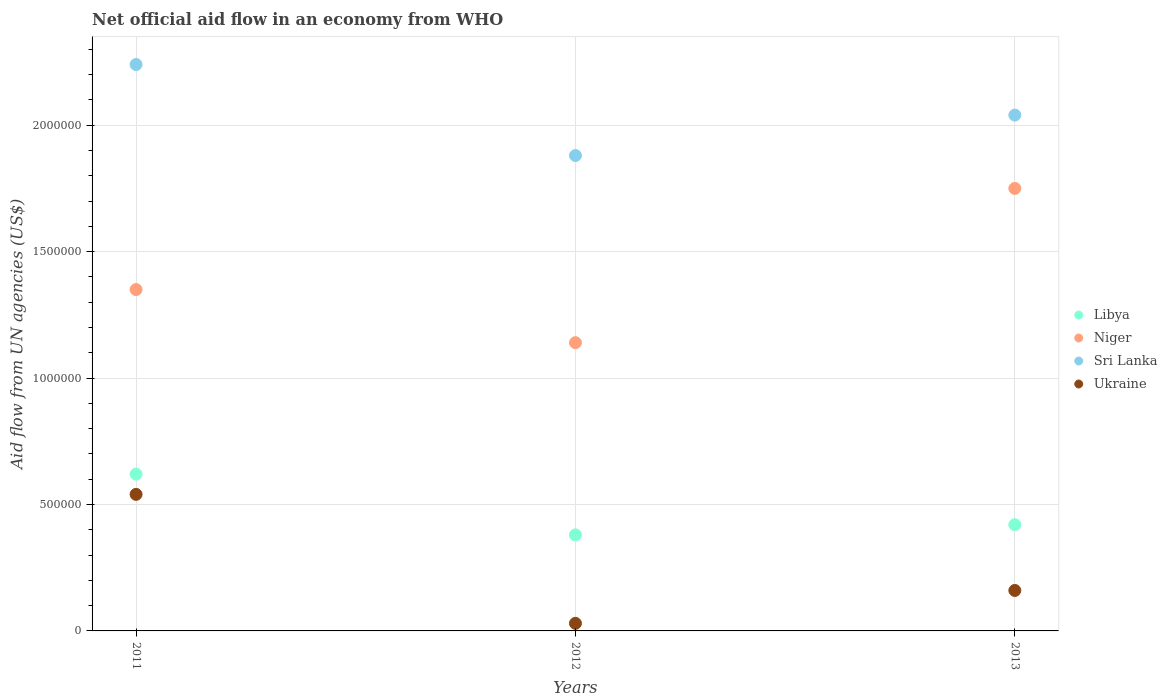Is the number of dotlines equal to the number of legend labels?
Your answer should be compact. Yes. Across all years, what is the maximum net official aid flow in Libya?
Offer a very short reply. 6.20e+05. Across all years, what is the minimum net official aid flow in Niger?
Ensure brevity in your answer.  1.14e+06. In which year was the net official aid flow in Ukraine minimum?
Your response must be concise. 2012. What is the total net official aid flow in Niger in the graph?
Keep it short and to the point. 4.24e+06. What is the difference between the net official aid flow in Niger in 2011 and the net official aid flow in Sri Lanka in 2013?
Your response must be concise. -6.90e+05. What is the average net official aid flow in Niger per year?
Offer a very short reply. 1.41e+06. In the year 2013, what is the difference between the net official aid flow in Ukraine and net official aid flow in Niger?
Offer a terse response. -1.59e+06. In how many years, is the net official aid flow in Ukraine greater than 1800000 US$?
Provide a succinct answer. 0. What is the ratio of the net official aid flow in Ukraine in 2011 to that in 2013?
Make the answer very short. 3.38. Is the net official aid flow in Ukraine in 2011 less than that in 2013?
Provide a short and direct response. No. In how many years, is the net official aid flow in Niger greater than the average net official aid flow in Niger taken over all years?
Your answer should be compact. 1. Is it the case that in every year, the sum of the net official aid flow in Ukraine and net official aid flow in Libya  is greater than the sum of net official aid flow in Niger and net official aid flow in Sri Lanka?
Ensure brevity in your answer.  No. Is it the case that in every year, the sum of the net official aid flow in Ukraine and net official aid flow in Libya  is greater than the net official aid flow in Sri Lanka?
Make the answer very short. No. Does the net official aid flow in Niger monotonically increase over the years?
Provide a succinct answer. No. Is the net official aid flow in Niger strictly less than the net official aid flow in Sri Lanka over the years?
Provide a succinct answer. Yes. How many dotlines are there?
Give a very brief answer. 4. What is the difference between two consecutive major ticks on the Y-axis?
Keep it short and to the point. 5.00e+05. Are the values on the major ticks of Y-axis written in scientific E-notation?
Provide a succinct answer. No. What is the title of the graph?
Offer a very short reply. Net official aid flow in an economy from WHO. Does "Cambodia" appear as one of the legend labels in the graph?
Ensure brevity in your answer.  No. What is the label or title of the X-axis?
Keep it short and to the point. Years. What is the label or title of the Y-axis?
Keep it short and to the point. Aid flow from UN agencies (US$). What is the Aid flow from UN agencies (US$) in Libya in 2011?
Offer a very short reply. 6.20e+05. What is the Aid flow from UN agencies (US$) of Niger in 2011?
Give a very brief answer. 1.35e+06. What is the Aid flow from UN agencies (US$) in Sri Lanka in 2011?
Provide a short and direct response. 2.24e+06. What is the Aid flow from UN agencies (US$) of Ukraine in 2011?
Your answer should be very brief. 5.40e+05. What is the Aid flow from UN agencies (US$) in Libya in 2012?
Provide a succinct answer. 3.80e+05. What is the Aid flow from UN agencies (US$) of Niger in 2012?
Give a very brief answer. 1.14e+06. What is the Aid flow from UN agencies (US$) in Sri Lanka in 2012?
Provide a short and direct response. 1.88e+06. What is the Aid flow from UN agencies (US$) of Libya in 2013?
Offer a terse response. 4.20e+05. What is the Aid flow from UN agencies (US$) of Niger in 2013?
Give a very brief answer. 1.75e+06. What is the Aid flow from UN agencies (US$) in Sri Lanka in 2013?
Offer a very short reply. 2.04e+06. Across all years, what is the maximum Aid flow from UN agencies (US$) in Libya?
Make the answer very short. 6.20e+05. Across all years, what is the maximum Aid flow from UN agencies (US$) of Niger?
Your response must be concise. 1.75e+06. Across all years, what is the maximum Aid flow from UN agencies (US$) of Sri Lanka?
Offer a very short reply. 2.24e+06. Across all years, what is the maximum Aid flow from UN agencies (US$) in Ukraine?
Your response must be concise. 5.40e+05. Across all years, what is the minimum Aid flow from UN agencies (US$) of Libya?
Your response must be concise. 3.80e+05. Across all years, what is the minimum Aid flow from UN agencies (US$) in Niger?
Your answer should be compact. 1.14e+06. Across all years, what is the minimum Aid flow from UN agencies (US$) in Sri Lanka?
Offer a very short reply. 1.88e+06. What is the total Aid flow from UN agencies (US$) in Libya in the graph?
Offer a terse response. 1.42e+06. What is the total Aid flow from UN agencies (US$) in Niger in the graph?
Your answer should be compact. 4.24e+06. What is the total Aid flow from UN agencies (US$) of Sri Lanka in the graph?
Provide a succinct answer. 6.16e+06. What is the total Aid flow from UN agencies (US$) of Ukraine in the graph?
Your answer should be very brief. 7.30e+05. What is the difference between the Aid flow from UN agencies (US$) of Libya in 2011 and that in 2012?
Ensure brevity in your answer.  2.40e+05. What is the difference between the Aid flow from UN agencies (US$) of Ukraine in 2011 and that in 2012?
Your response must be concise. 5.10e+05. What is the difference between the Aid flow from UN agencies (US$) of Libya in 2011 and that in 2013?
Offer a terse response. 2.00e+05. What is the difference between the Aid flow from UN agencies (US$) of Niger in 2011 and that in 2013?
Ensure brevity in your answer.  -4.00e+05. What is the difference between the Aid flow from UN agencies (US$) of Libya in 2012 and that in 2013?
Keep it short and to the point. -4.00e+04. What is the difference between the Aid flow from UN agencies (US$) of Niger in 2012 and that in 2013?
Your response must be concise. -6.10e+05. What is the difference between the Aid flow from UN agencies (US$) of Sri Lanka in 2012 and that in 2013?
Your answer should be compact. -1.60e+05. What is the difference between the Aid flow from UN agencies (US$) in Ukraine in 2012 and that in 2013?
Keep it short and to the point. -1.30e+05. What is the difference between the Aid flow from UN agencies (US$) in Libya in 2011 and the Aid flow from UN agencies (US$) in Niger in 2012?
Ensure brevity in your answer.  -5.20e+05. What is the difference between the Aid flow from UN agencies (US$) in Libya in 2011 and the Aid flow from UN agencies (US$) in Sri Lanka in 2012?
Your response must be concise. -1.26e+06. What is the difference between the Aid flow from UN agencies (US$) of Libya in 2011 and the Aid flow from UN agencies (US$) of Ukraine in 2012?
Your answer should be compact. 5.90e+05. What is the difference between the Aid flow from UN agencies (US$) of Niger in 2011 and the Aid flow from UN agencies (US$) of Sri Lanka in 2012?
Your answer should be very brief. -5.30e+05. What is the difference between the Aid flow from UN agencies (US$) of Niger in 2011 and the Aid flow from UN agencies (US$) of Ukraine in 2012?
Make the answer very short. 1.32e+06. What is the difference between the Aid flow from UN agencies (US$) of Sri Lanka in 2011 and the Aid flow from UN agencies (US$) of Ukraine in 2012?
Your answer should be very brief. 2.21e+06. What is the difference between the Aid flow from UN agencies (US$) in Libya in 2011 and the Aid flow from UN agencies (US$) in Niger in 2013?
Keep it short and to the point. -1.13e+06. What is the difference between the Aid flow from UN agencies (US$) in Libya in 2011 and the Aid flow from UN agencies (US$) in Sri Lanka in 2013?
Ensure brevity in your answer.  -1.42e+06. What is the difference between the Aid flow from UN agencies (US$) of Niger in 2011 and the Aid flow from UN agencies (US$) of Sri Lanka in 2013?
Offer a very short reply. -6.90e+05. What is the difference between the Aid flow from UN agencies (US$) of Niger in 2011 and the Aid flow from UN agencies (US$) of Ukraine in 2013?
Keep it short and to the point. 1.19e+06. What is the difference between the Aid flow from UN agencies (US$) of Sri Lanka in 2011 and the Aid flow from UN agencies (US$) of Ukraine in 2013?
Make the answer very short. 2.08e+06. What is the difference between the Aid flow from UN agencies (US$) of Libya in 2012 and the Aid flow from UN agencies (US$) of Niger in 2013?
Keep it short and to the point. -1.37e+06. What is the difference between the Aid flow from UN agencies (US$) in Libya in 2012 and the Aid flow from UN agencies (US$) in Sri Lanka in 2013?
Offer a terse response. -1.66e+06. What is the difference between the Aid flow from UN agencies (US$) in Niger in 2012 and the Aid flow from UN agencies (US$) in Sri Lanka in 2013?
Make the answer very short. -9.00e+05. What is the difference between the Aid flow from UN agencies (US$) in Niger in 2012 and the Aid flow from UN agencies (US$) in Ukraine in 2013?
Offer a terse response. 9.80e+05. What is the difference between the Aid flow from UN agencies (US$) of Sri Lanka in 2012 and the Aid flow from UN agencies (US$) of Ukraine in 2013?
Keep it short and to the point. 1.72e+06. What is the average Aid flow from UN agencies (US$) of Libya per year?
Offer a very short reply. 4.73e+05. What is the average Aid flow from UN agencies (US$) of Niger per year?
Offer a terse response. 1.41e+06. What is the average Aid flow from UN agencies (US$) of Sri Lanka per year?
Make the answer very short. 2.05e+06. What is the average Aid flow from UN agencies (US$) of Ukraine per year?
Ensure brevity in your answer.  2.43e+05. In the year 2011, what is the difference between the Aid flow from UN agencies (US$) in Libya and Aid flow from UN agencies (US$) in Niger?
Offer a terse response. -7.30e+05. In the year 2011, what is the difference between the Aid flow from UN agencies (US$) of Libya and Aid flow from UN agencies (US$) of Sri Lanka?
Provide a short and direct response. -1.62e+06. In the year 2011, what is the difference between the Aid flow from UN agencies (US$) in Libya and Aid flow from UN agencies (US$) in Ukraine?
Provide a succinct answer. 8.00e+04. In the year 2011, what is the difference between the Aid flow from UN agencies (US$) of Niger and Aid flow from UN agencies (US$) of Sri Lanka?
Make the answer very short. -8.90e+05. In the year 2011, what is the difference between the Aid flow from UN agencies (US$) in Niger and Aid flow from UN agencies (US$) in Ukraine?
Your answer should be very brief. 8.10e+05. In the year 2011, what is the difference between the Aid flow from UN agencies (US$) of Sri Lanka and Aid flow from UN agencies (US$) of Ukraine?
Provide a succinct answer. 1.70e+06. In the year 2012, what is the difference between the Aid flow from UN agencies (US$) of Libya and Aid flow from UN agencies (US$) of Niger?
Your answer should be compact. -7.60e+05. In the year 2012, what is the difference between the Aid flow from UN agencies (US$) of Libya and Aid flow from UN agencies (US$) of Sri Lanka?
Provide a short and direct response. -1.50e+06. In the year 2012, what is the difference between the Aid flow from UN agencies (US$) of Niger and Aid flow from UN agencies (US$) of Sri Lanka?
Give a very brief answer. -7.40e+05. In the year 2012, what is the difference between the Aid flow from UN agencies (US$) of Niger and Aid flow from UN agencies (US$) of Ukraine?
Ensure brevity in your answer.  1.11e+06. In the year 2012, what is the difference between the Aid flow from UN agencies (US$) of Sri Lanka and Aid flow from UN agencies (US$) of Ukraine?
Your answer should be very brief. 1.85e+06. In the year 2013, what is the difference between the Aid flow from UN agencies (US$) of Libya and Aid flow from UN agencies (US$) of Niger?
Your answer should be very brief. -1.33e+06. In the year 2013, what is the difference between the Aid flow from UN agencies (US$) in Libya and Aid flow from UN agencies (US$) in Sri Lanka?
Your answer should be compact. -1.62e+06. In the year 2013, what is the difference between the Aid flow from UN agencies (US$) of Libya and Aid flow from UN agencies (US$) of Ukraine?
Provide a short and direct response. 2.60e+05. In the year 2013, what is the difference between the Aid flow from UN agencies (US$) of Niger and Aid flow from UN agencies (US$) of Sri Lanka?
Your answer should be very brief. -2.90e+05. In the year 2013, what is the difference between the Aid flow from UN agencies (US$) of Niger and Aid flow from UN agencies (US$) of Ukraine?
Give a very brief answer. 1.59e+06. In the year 2013, what is the difference between the Aid flow from UN agencies (US$) in Sri Lanka and Aid flow from UN agencies (US$) in Ukraine?
Keep it short and to the point. 1.88e+06. What is the ratio of the Aid flow from UN agencies (US$) in Libya in 2011 to that in 2012?
Provide a succinct answer. 1.63. What is the ratio of the Aid flow from UN agencies (US$) in Niger in 2011 to that in 2012?
Your response must be concise. 1.18. What is the ratio of the Aid flow from UN agencies (US$) in Sri Lanka in 2011 to that in 2012?
Your response must be concise. 1.19. What is the ratio of the Aid flow from UN agencies (US$) of Ukraine in 2011 to that in 2012?
Ensure brevity in your answer.  18. What is the ratio of the Aid flow from UN agencies (US$) of Libya in 2011 to that in 2013?
Provide a short and direct response. 1.48. What is the ratio of the Aid flow from UN agencies (US$) in Niger in 2011 to that in 2013?
Keep it short and to the point. 0.77. What is the ratio of the Aid flow from UN agencies (US$) in Sri Lanka in 2011 to that in 2013?
Make the answer very short. 1.1. What is the ratio of the Aid flow from UN agencies (US$) in Ukraine in 2011 to that in 2013?
Keep it short and to the point. 3.38. What is the ratio of the Aid flow from UN agencies (US$) of Libya in 2012 to that in 2013?
Make the answer very short. 0.9. What is the ratio of the Aid flow from UN agencies (US$) of Niger in 2012 to that in 2013?
Offer a terse response. 0.65. What is the ratio of the Aid flow from UN agencies (US$) of Sri Lanka in 2012 to that in 2013?
Your answer should be compact. 0.92. What is the ratio of the Aid flow from UN agencies (US$) of Ukraine in 2012 to that in 2013?
Ensure brevity in your answer.  0.19. What is the difference between the highest and the second highest Aid flow from UN agencies (US$) in Niger?
Your response must be concise. 4.00e+05. What is the difference between the highest and the second highest Aid flow from UN agencies (US$) of Ukraine?
Provide a succinct answer. 3.80e+05. What is the difference between the highest and the lowest Aid flow from UN agencies (US$) of Libya?
Your answer should be very brief. 2.40e+05. What is the difference between the highest and the lowest Aid flow from UN agencies (US$) of Ukraine?
Keep it short and to the point. 5.10e+05. 